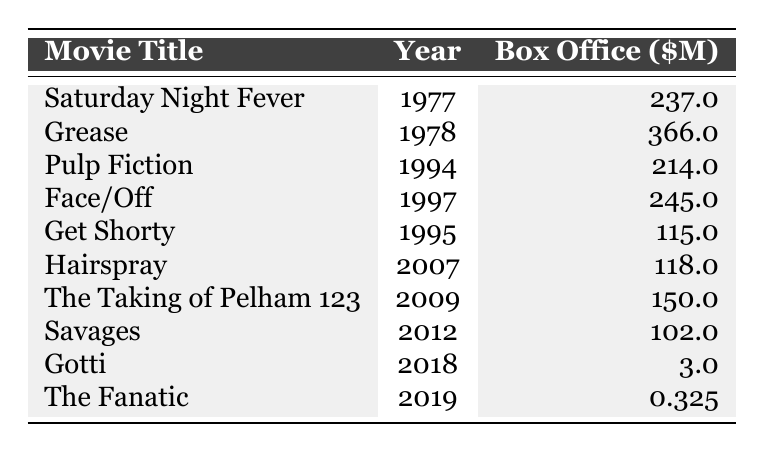What movie had the highest box office earnings? From the table, we can see that "Grease" has the highest box office earnings of $366 million.
Answer: Grease In which year was "Pulp Fiction" released? The table directly lists that "Pulp Fiction" was released in 1994.
Answer: 1994 What is the box office earnings of "Gotti"? The earnings for "Gotti" are shown in the table as $3 million.
Answer: 3 million Which two movies had box office earnings greater than $200 million? The table shows that "Grease" with $366 million and "Face/Off" with $245 million both had earnings greater than $200 million.
Answer: Grease and Face/Off Calculate the average box office earnings of the movies listed. First, we sum all box office earnings: (237 + 366 + 214 + 245 + 115 + 118 + 150 + 102 + 3 + 0.325) = 1250.325 million. There are 10 movies. The average is 1250.325 / 10 = 125.0325 million.
Answer: 125.03 million Did "The Fanatic" earn more than "Savages"? According to the table, "The Fanatic" earned $0.325 million while "Savages" earned $102 million, so "The Fanatic" earned less than "Savages".
Answer: No What is the difference in box office earnings between "Saturday Night Fever" and "Hairspray"? We subtract the earnings of "Hairspray" ($118 million) from "Saturday Night Fever" ($237 million). The difference is 237 - 118 = 119 million.
Answer: 119 million How many movies listed were released after the year 2000? The table shows that "Hairspray" (2007), "The Taking of Pelham 123" (2009), "Savages" (2012), "Gotti" (2018), and "The Fanatic" (2019) were released after 2000, totaling 5 movies.
Answer: 5 Which movie had the lowest box office earnings? From the table, it's clear that "The Fanatic" had the lowest box office earnings of $0.325 million.
Answer: The Fanatic Is it true that "Face/Off" earned more than "Pulp Fiction"? The box office earnings shown in the table indicate "Face/Off" earned $245 million, while "Pulp Fiction" earned $214 million, making the statement true.
Answer: Yes 